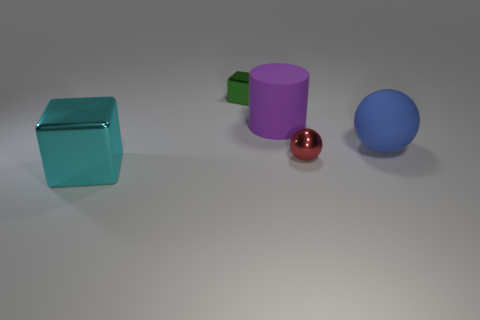Add 2 metallic balls. How many objects exist? 7 Subtract all cubes. How many objects are left? 3 Add 5 green metallic objects. How many green metallic objects exist? 6 Subtract 1 blue spheres. How many objects are left? 4 Subtract all purple things. Subtract all red metal balls. How many objects are left? 3 Add 4 small spheres. How many small spheres are left? 5 